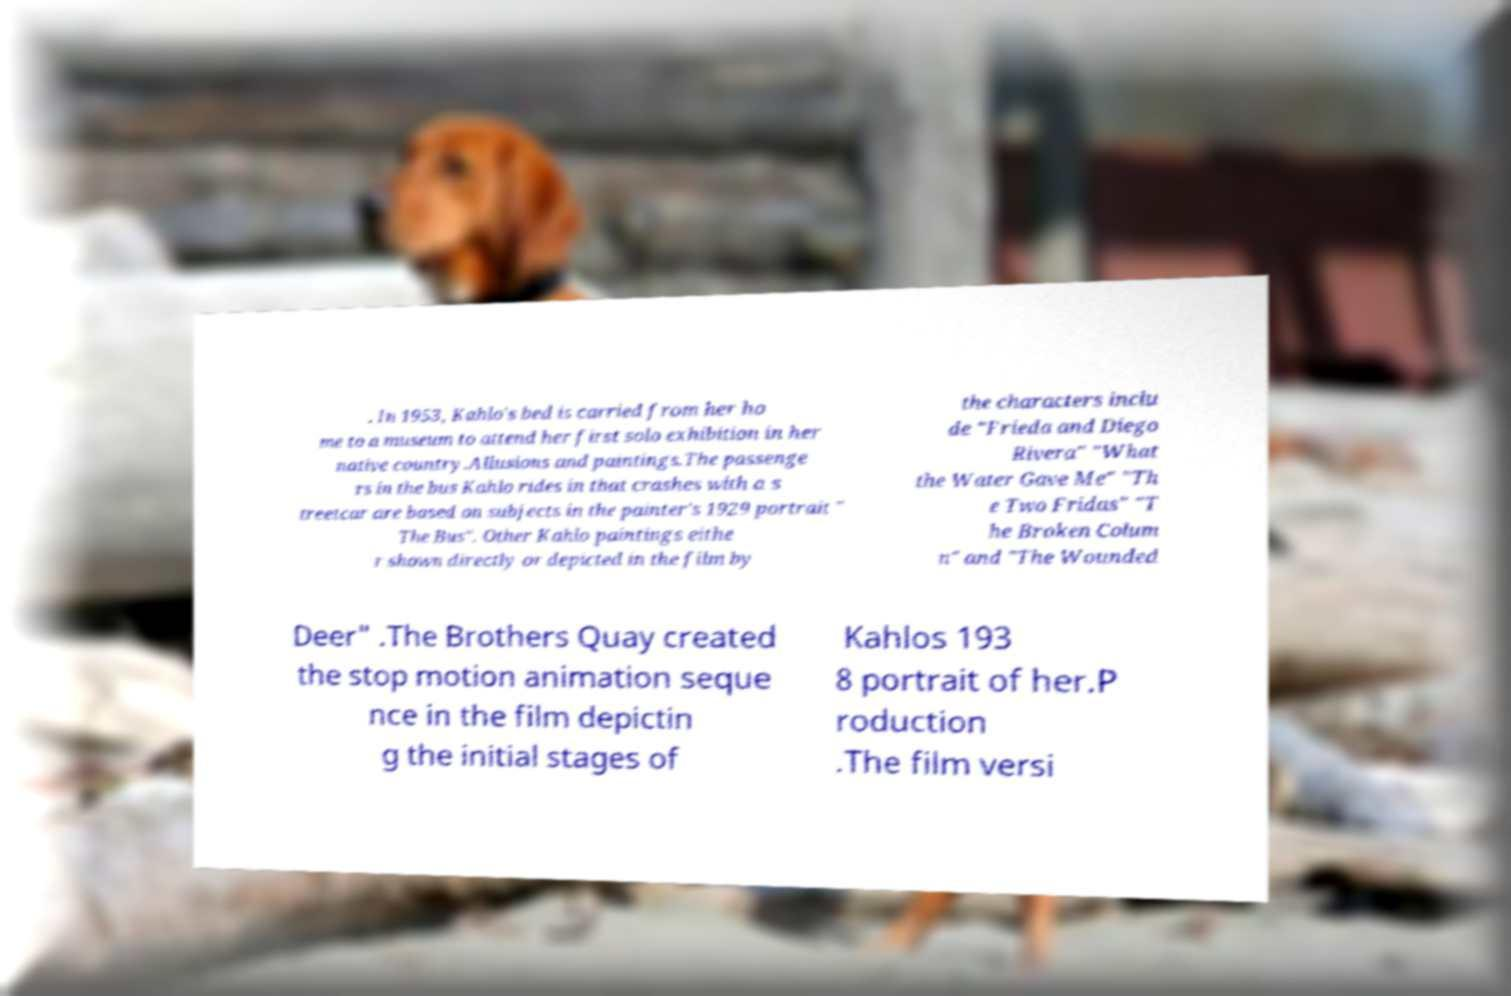Can you accurately transcribe the text from the provided image for me? . In 1953, Kahlo's bed is carried from her ho me to a museum to attend her first solo exhibition in her native country.Allusions and paintings.The passenge rs in the bus Kahlo rides in that crashes with a s treetcar are based on subjects in the painter's 1929 portrait " The Bus". Other Kahlo paintings eithe r shown directly or depicted in the film by the characters inclu de "Frieda and Diego Rivera" "What the Water Gave Me" "Th e Two Fridas" "T he Broken Colum n" and "The Wounded Deer" .The Brothers Quay created the stop motion animation seque nce in the film depictin g the initial stages of Kahlos 193 8 portrait of her.P roduction .The film versi 